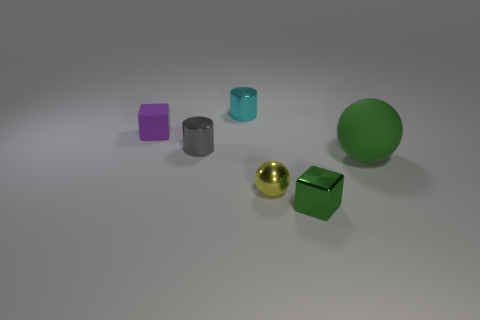Add 3 cyan metallic things. How many objects exist? 9 Subtract all blocks. How many objects are left? 4 Subtract all green shiny things. Subtract all large blue rubber cubes. How many objects are left? 5 Add 3 tiny metal cylinders. How many tiny metal cylinders are left? 5 Add 1 small blue matte blocks. How many small blue matte blocks exist? 1 Subtract 0 purple cylinders. How many objects are left? 6 